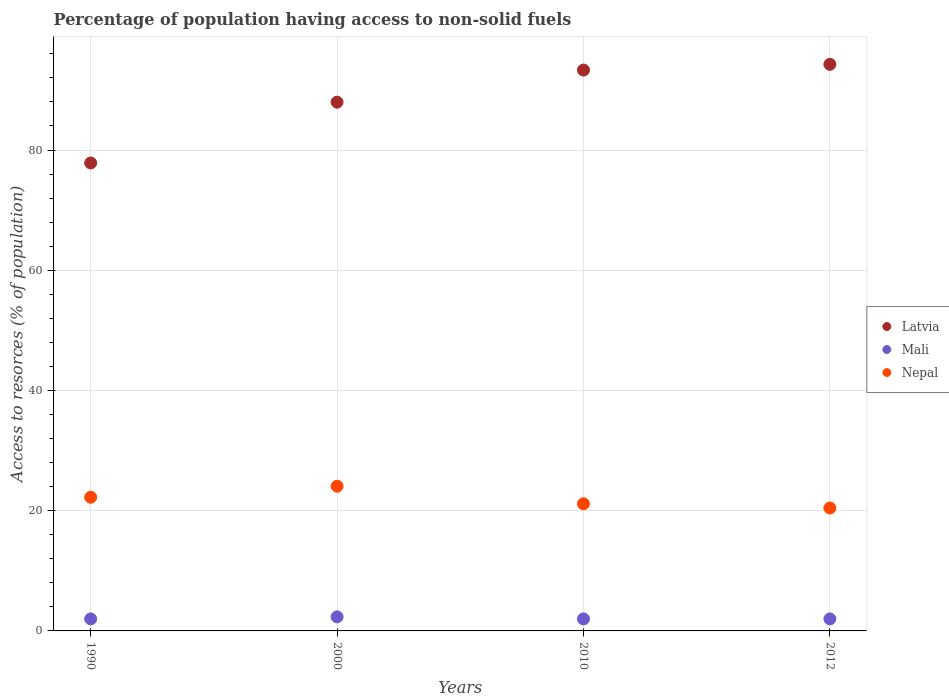How many different coloured dotlines are there?
Keep it short and to the point. 3. What is the percentage of population having access to non-solid fuels in Mali in 2012?
Your answer should be very brief. 2. Across all years, what is the maximum percentage of population having access to non-solid fuels in Nepal?
Provide a short and direct response. 24.07. Across all years, what is the minimum percentage of population having access to non-solid fuels in Latvia?
Your answer should be compact. 77.85. In which year was the percentage of population having access to non-solid fuels in Latvia minimum?
Provide a succinct answer. 1990. What is the total percentage of population having access to non-solid fuels in Latvia in the graph?
Keep it short and to the point. 353.38. What is the difference between the percentage of population having access to non-solid fuels in Nepal in 2000 and that in 2010?
Make the answer very short. 2.92. What is the difference between the percentage of population having access to non-solid fuels in Latvia in 1990 and the percentage of population having access to non-solid fuels in Nepal in 2012?
Ensure brevity in your answer.  57.4. What is the average percentage of population having access to non-solid fuels in Latvia per year?
Offer a terse response. 88.35. In the year 1990, what is the difference between the percentage of population having access to non-solid fuels in Mali and percentage of population having access to non-solid fuels in Nepal?
Make the answer very short. -20.24. In how many years, is the percentage of population having access to non-solid fuels in Latvia greater than 12 %?
Your answer should be compact. 4. What is the ratio of the percentage of population having access to non-solid fuels in Nepal in 2000 to that in 2012?
Offer a terse response. 1.18. Is the difference between the percentage of population having access to non-solid fuels in Mali in 2010 and 2012 greater than the difference between the percentage of population having access to non-solid fuels in Nepal in 2010 and 2012?
Provide a succinct answer. No. What is the difference between the highest and the second highest percentage of population having access to non-solid fuels in Nepal?
Your answer should be compact. 1.83. What is the difference between the highest and the lowest percentage of population having access to non-solid fuels in Latvia?
Give a very brief answer. 16.41. Does the percentage of population having access to non-solid fuels in Mali monotonically increase over the years?
Your answer should be compact. No. Is the percentage of population having access to non-solid fuels in Mali strictly greater than the percentage of population having access to non-solid fuels in Nepal over the years?
Your response must be concise. No. How many dotlines are there?
Provide a succinct answer. 3. What is the difference between two consecutive major ticks on the Y-axis?
Ensure brevity in your answer.  20. Are the values on the major ticks of Y-axis written in scientific E-notation?
Give a very brief answer. No. How many legend labels are there?
Offer a very short reply. 3. How are the legend labels stacked?
Your answer should be very brief. Vertical. What is the title of the graph?
Make the answer very short. Percentage of population having access to non-solid fuels. What is the label or title of the X-axis?
Provide a short and direct response. Years. What is the label or title of the Y-axis?
Provide a succinct answer. Access to resorces (% of population). What is the Access to resorces (% of population) in Latvia in 1990?
Make the answer very short. 77.85. What is the Access to resorces (% of population) of Mali in 1990?
Keep it short and to the point. 2. What is the Access to resorces (% of population) of Nepal in 1990?
Your answer should be compact. 22.24. What is the Access to resorces (% of population) of Latvia in 2000?
Keep it short and to the point. 87.97. What is the Access to resorces (% of population) in Mali in 2000?
Offer a terse response. 2.34. What is the Access to resorces (% of population) in Nepal in 2000?
Provide a succinct answer. 24.07. What is the Access to resorces (% of population) of Latvia in 2010?
Make the answer very short. 93.31. What is the Access to resorces (% of population) of Mali in 2010?
Your answer should be very brief. 2. What is the Access to resorces (% of population) in Nepal in 2010?
Your response must be concise. 21.15. What is the Access to resorces (% of population) in Latvia in 2012?
Provide a succinct answer. 94.26. What is the Access to resorces (% of population) of Mali in 2012?
Offer a terse response. 2. What is the Access to resorces (% of population) of Nepal in 2012?
Your response must be concise. 20.45. Across all years, what is the maximum Access to resorces (% of population) of Latvia?
Ensure brevity in your answer.  94.26. Across all years, what is the maximum Access to resorces (% of population) of Mali?
Keep it short and to the point. 2.34. Across all years, what is the maximum Access to resorces (% of population) of Nepal?
Provide a short and direct response. 24.07. Across all years, what is the minimum Access to resorces (% of population) in Latvia?
Make the answer very short. 77.85. Across all years, what is the minimum Access to resorces (% of population) in Mali?
Provide a short and direct response. 2. Across all years, what is the minimum Access to resorces (% of population) of Nepal?
Your answer should be very brief. 20.45. What is the total Access to resorces (% of population) of Latvia in the graph?
Provide a succinct answer. 353.38. What is the total Access to resorces (% of population) in Mali in the graph?
Provide a short and direct response. 8.34. What is the total Access to resorces (% of population) in Nepal in the graph?
Make the answer very short. 87.91. What is the difference between the Access to resorces (% of population) in Latvia in 1990 and that in 2000?
Your answer should be compact. -10.12. What is the difference between the Access to resorces (% of population) of Mali in 1990 and that in 2000?
Offer a very short reply. -0.34. What is the difference between the Access to resorces (% of population) of Nepal in 1990 and that in 2000?
Ensure brevity in your answer.  -1.83. What is the difference between the Access to resorces (% of population) in Latvia in 1990 and that in 2010?
Your answer should be compact. -15.46. What is the difference between the Access to resorces (% of population) of Nepal in 1990 and that in 2010?
Ensure brevity in your answer.  1.09. What is the difference between the Access to resorces (% of population) of Latvia in 1990 and that in 2012?
Provide a succinct answer. -16.41. What is the difference between the Access to resorces (% of population) of Mali in 1990 and that in 2012?
Keep it short and to the point. 0. What is the difference between the Access to resorces (% of population) in Nepal in 1990 and that in 2012?
Ensure brevity in your answer.  1.79. What is the difference between the Access to resorces (% of population) of Latvia in 2000 and that in 2010?
Keep it short and to the point. -5.34. What is the difference between the Access to resorces (% of population) in Mali in 2000 and that in 2010?
Ensure brevity in your answer.  0.34. What is the difference between the Access to resorces (% of population) in Nepal in 2000 and that in 2010?
Keep it short and to the point. 2.92. What is the difference between the Access to resorces (% of population) in Latvia in 2000 and that in 2012?
Make the answer very short. -6.3. What is the difference between the Access to resorces (% of population) in Mali in 2000 and that in 2012?
Ensure brevity in your answer.  0.34. What is the difference between the Access to resorces (% of population) in Nepal in 2000 and that in 2012?
Provide a succinct answer. 3.62. What is the difference between the Access to resorces (% of population) in Latvia in 2010 and that in 2012?
Your answer should be compact. -0.96. What is the difference between the Access to resorces (% of population) of Mali in 2010 and that in 2012?
Give a very brief answer. 0. What is the difference between the Access to resorces (% of population) in Nepal in 2010 and that in 2012?
Give a very brief answer. 0.7. What is the difference between the Access to resorces (% of population) of Latvia in 1990 and the Access to resorces (% of population) of Mali in 2000?
Offer a terse response. 75.51. What is the difference between the Access to resorces (% of population) of Latvia in 1990 and the Access to resorces (% of population) of Nepal in 2000?
Make the answer very short. 53.78. What is the difference between the Access to resorces (% of population) of Mali in 1990 and the Access to resorces (% of population) of Nepal in 2000?
Your answer should be compact. -22.07. What is the difference between the Access to resorces (% of population) in Latvia in 1990 and the Access to resorces (% of population) in Mali in 2010?
Your answer should be very brief. 75.85. What is the difference between the Access to resorces (% of population) in Latvia in 1990 and the Access to resorces (% of population) in Nepal in 2010?
Your response must be concise. 56.7. What is the difference between the Access to resorces (% of population) of Mali in 1990 and the Access to resorces (% of population) of Nepal in 2010?
Offer a terse response. -19.15. What is the difference between the Access to resorces (% of population) in Latvia in 1990 and the Access to resorces (% of population) in Mali in 2012?
Offer a terse response. 75.85. What is the difference between the Access to resorces (% of population) in Latvia in 1990 and the Access to resorces (% of population) in Nepal in 2012?
Provide a succinct answer. 57.4. What is the difference between the Access to resorces (% of population) in Mali in 1990 and the Access to resorces (% of population) in Nepal in 2012?
Your answer should be very brief. -18.45. What is the difference between the Access to resorces (% of population) of Latvia in 2000 and the Access to resorces (% of population) of Mali in 2010?
Provide a short and direct response. 85.97. What is the difference between the Access to resorces (% of population) of Latvia in 2000 and the Access to resorces (% of population) of Nepal in 2010?
Ensure brevity in your answer.  66.82. What is the difference between the Access to resorces (% of population) of Mali in 2000 and the Access to resorces (% of population) of Nepal in 2010?
Make the answer very short. -18.81. What is the difference between the Access to resorces (% of population) in Latvia in 2000 and the Access to resorces (% of population) in Mali in 2012?
Offer a very short reply. 85.97. What is the difference between the Access to resorces (% of population) of Latvia in 2000 and the Access to resorces (% of population) of Nepal in 2012?
Offer a terse response. 67.51. What is the difference between the Access to resorces (% of population) of Mali in 2000 and the Access to resorces (% of population) of Nepal in 2012?
Provide a short and direct response. -18.11. What is the difference between the Access to resorces (% of population) in Latvia in 2010 and the Access to resorces (% of population) in Mali in 2012?
Your response must be concise. 91.31. What is the difference between the Access to resorces (% of population) of Latvia in 2010 and the Access to resorces (% of population) of Nepal in 2012?
Your response must be concise. 72.85. What is the difference between the Access to resorces (% of population) of Mali in 2010 and the Access to resorces (% of population) of Nepal in 2012?
Give a very brief answer. -18.45. What is the average Access to resorces (% of population) in Latvia per year?
Provide a short and direct response. 88.35. What is the average Access to resorces (% of population) in Mali per year?
Offer a terse response. 2.08. What is the average Access to resorces (% of population) in Nepal per year?
Offer a terse response. 21.98. In the year 1990, what is the difference between the Access to resorces (% of population) in Latvia and Access to resorces (% of population) in Mali?
Provide a short and direct response. 75.85. In the year 1990, what is the difference between the Access to resorces (% of population) of Latvia and Access to resorces (% of population) of Nepal?
Offer a terse response. 55.61. In the year 1990, what is the difference between the Access to resorces (% of population) in Mali and Access to resorces (% of population) in Nepal?
Your answer should be very brief. -20.24. In the year 2000, what is the difference between the Access to resorces (% of population) in Latvia and Access to resorces (% of population) in Mali?
Provide a succinct answer. 85.63. In the year 2000, what is the difference between the Access to resorces (% of population) in Latvia and Access to resorces (% of population) in Nepal?
Your answer should be compact. 63.89. In the year 2000, what is the difference between the Access to resorces (% of population) of Mali and Access to resorces (% of population) of Nepal?
Your answer should be very brief. -21.74. In the year 2010, what is the difference between the Access to resorces (% of population) in Latvia and Access to resorces (% of population) in Mali?
Make the answer very short. 91.31. In the year 2010, what is the difference between the Access to resorces (% of population) of Latvia and Access to resorces (% of population) of Nepal?
Make the answer very short. 72.16. In the year 2010, what is the difference between the Access to resorces (% of population) in Mali and Access to resorces (% of population) in Nepal?
Offer a very short reply. -19.15. In the year 2012, what is the difference between the Access to resorces (% of population) in Latvia and Access to resorces (% of population) in Mali?
Give a very brief answer. 92.26. In the year 2012, what is the difference between the Access to resorces (% of population) in Latvia and Access to resorces (% of population) in Nepal?
Your answer should be compact. 73.81. In the year 2012, what is the difference between the Access to resorces (% of population) of Mali and Access to resorces (% of population) of Nepal?
Provide a short and direct response. -18.45. What is the ratio of the Access to resorces (% of population) of Latvia in 1990 to that in 2000?
Provide a succinct answer. 0.89. What is the ratio of the Access to resorces (% of population) in Mali in 1990 to that in 2000?
Offer a very short reply. 0.86. What is the ratio of the Access to resorces (% of population) of Nepal in 1990 to that in 2000?
Your answer should be compact. 0.92. What is the ratio of the Access to resorces (% of population) of Latvia in 1990 to that in 2010?
Offer a very short reply. 0.83. What is the ratio of the Access to resorces (% of population) in Mali in 1990 to that in 2010?
Keep it short and to the point. 1. What is the ratio of the Access to resorces (% of population) in Nepal in 1990 to that in 2010?
Keep it short and to the point. 1.05. What is the ratio of the Access to resorces (% of population) in Latvia in 1990 to that in 2012?
Provide a succinct answer. 0.83. What is the ratio of the Access to resorces (% of population) in Nepal in 1990 to that in 2012?
Make the answer very short. 1.09. What is the ratio of the Access to resorces (% of population) of Latvia in 2000 to that in 2010?
Provide a succinct answer. 0.94. What is the ratio of the Access to resorces (% of population) in Mali in 2000 to that in 2010?
Your response must be concise. 1.17. What is the ratio of the Access to resorces (% of population) in Nepal in 2000 to that in 2010?
Offer a terse response. 1.14. What is the ratio of the Access to resorces (% of population) in Latvia in 2000 to that in 2012?
Your answer should be very brief. 0.93. What is the ratio of the Access to resorces (% of population) of Mali in 2000 to that in 2012?
Provide a short and direct response. 1.17. What is the ratio of the Access to resorces (% of population) in Nepal in 2000 to that in 2012?
Provide a short and direct response. 1.18. What is the ratio of the Access to resorces (% of population) of Mali in 2010 to that in 2012?
Make the answer very short. 1. What is the ratio of the Access to resorces (% of population) in Nepal in 2010 to that in 2012?
Your answer should be very brief. 1.03. What is the difference between the highest and the second highest Access to resorces (% of population) of Latvia?
Give a very brief answer. 0.96. What is the difference between the highest and the second highest Access to resorces (% of population) of Mali?
Keep it short and to the point. 0.34. What is the difference between the highest and the second highest Access to resorces (% of population) in Nepal?
Your response must be concise. 1.83. What is the difference between the highest and the lowest Access to resorces (% of population) in Latvia?
Provide a short and direct response. 16.41. What is the difference between the highest and the lowest Access to resorces (% of population) of Mali?
Your response must be concise. 0.34. What is the difference between the highest and the lowest Access to resorces (% of population) in Nepal?
Your answer should be compact. 3.62. 